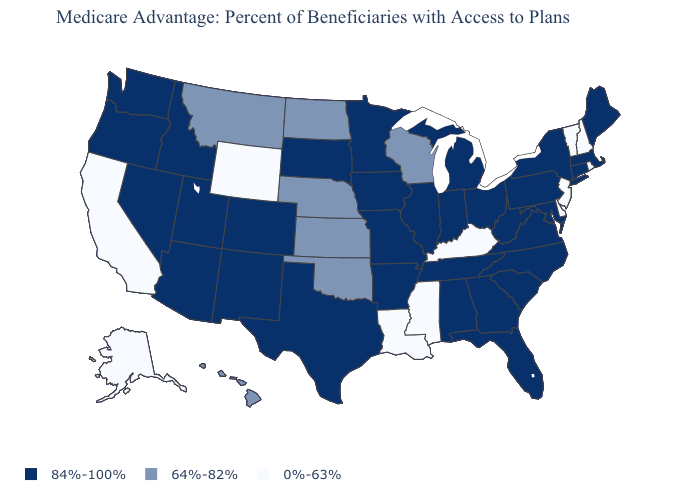Name the states that have a value in the range 64%-82%?
Answer briefly. Hawaii, Kansas, Montana, North Dakota, Nebraska, Oklahoma, Wisconsin. Name the states that have a value in the range 84%-100%?
Short answer required. Alabama, Arkansas, Arizona, Colorado, Connecticut, Florida, Georgia, Iowa, Idaho, Illinois, Indiana, Massachusetts, Maryland, Maine, Michigan, Minnesota, Missouri, North Carolina, New Mexico, Nevada, New York, Ohio, Oregon, Pennsylvania, South Carolina, South Dakota, Tennessee, Texas, Utah, Virginia, Washington, West Virginia. How many symbols are there in the legend?
Write a very short answer. 3. What is the value of Mississippi?
Keep it brief. 0%-63%. Among the states that border Mississippi , does Louisiana have the highest value?
Keep it brief. No. What is the value of Nebraska?
Concise answer only. 64%-82%. What is the value of Idaho?
Give a very brief answer. 84%-100%. What is the value of South Dakota?
Concise answer only. 84%-100%. Name the states that have a value in the range 84%-100%?
Short answer required. Alabama, Arkansas, Arizona, Colorado, Connecticut, Florida, Georgia, Iowa, Idaho, Illinois, Indiana, Massachusetts, Maryland, Maine, Michigan, Minnesota, Missouri, North Carolina, New Mexico, Nevada, New York, Ohio, Oregon, Pennsylvania, South Carolina, South Dakota, Tennessee, Texas, Utah, Virginia, Washington, West Virginia. What is the value of Massachusetts?
Keep it brief. 84%-100%. Is the legend a continuous bar?
Be succinct. No. Is the legend a continuous bar?
Be succinct. No. How many symbols are there in the legend?
Answer briefly. 3. What is the value of North Dakota?
Short answer required. 64%-82%. What is the highest value in the USA?
Short answer required. 84%-100%. 